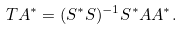<formula> <loc_0><loc_0><loc_500><loc_500>T A ^ { * } = ( S ^ { * } S ) ^ { - 1 } S ^ { * } A A ^ { * } .</formula> 